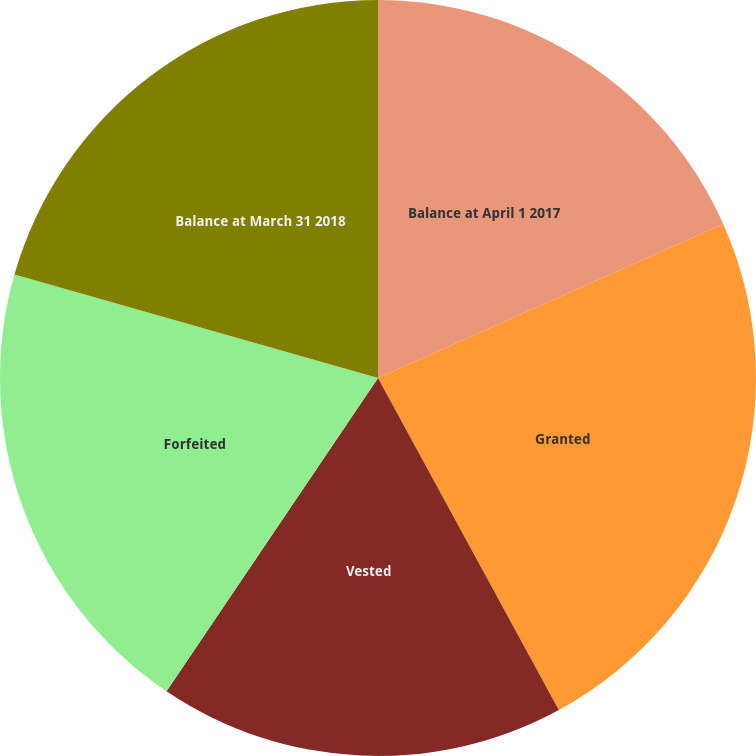<chart> <loc_0><loc_0><loc_500><loc_500><pie_chart><fcel>Balance at April 1 2017<fcel>Granted<fcel>Vested<fcel>Forfeited<fcel>Balance at March 31 2018<nl><fcel>18.32%<fcel>23.74%<fcel>17.39%<fcel>19.96%<fcel>20.59%<nl></chart> 